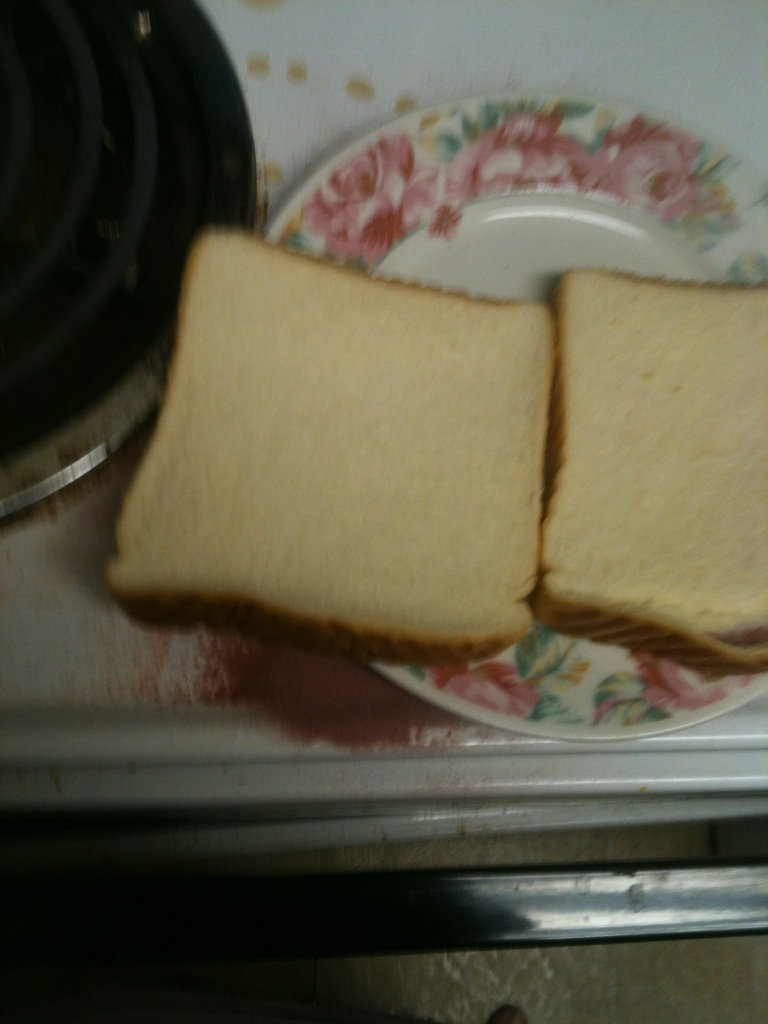Is this kind of bread suitable for a particular type of diet or meal? This plain white bread is versatile and can be used for a variety of meals, from sandwiches to toast. However, it's not ideal for diets that require low-carbohydrate or high-fiber intake, such as keto or whole food diets. It's more suitable for a classic diet that doesn't have particular restrictions. How can I tell if bread like this is fresh without tasting it? To assess the freshness of bread without tasting it, you can look for a springy texture when you gently press it—it should bounce back rather than stay compressed. Also, check for any uneven coloration or spots that could indicate the onset of mold, and smell it for any off odors, which suggest it's past its best. 